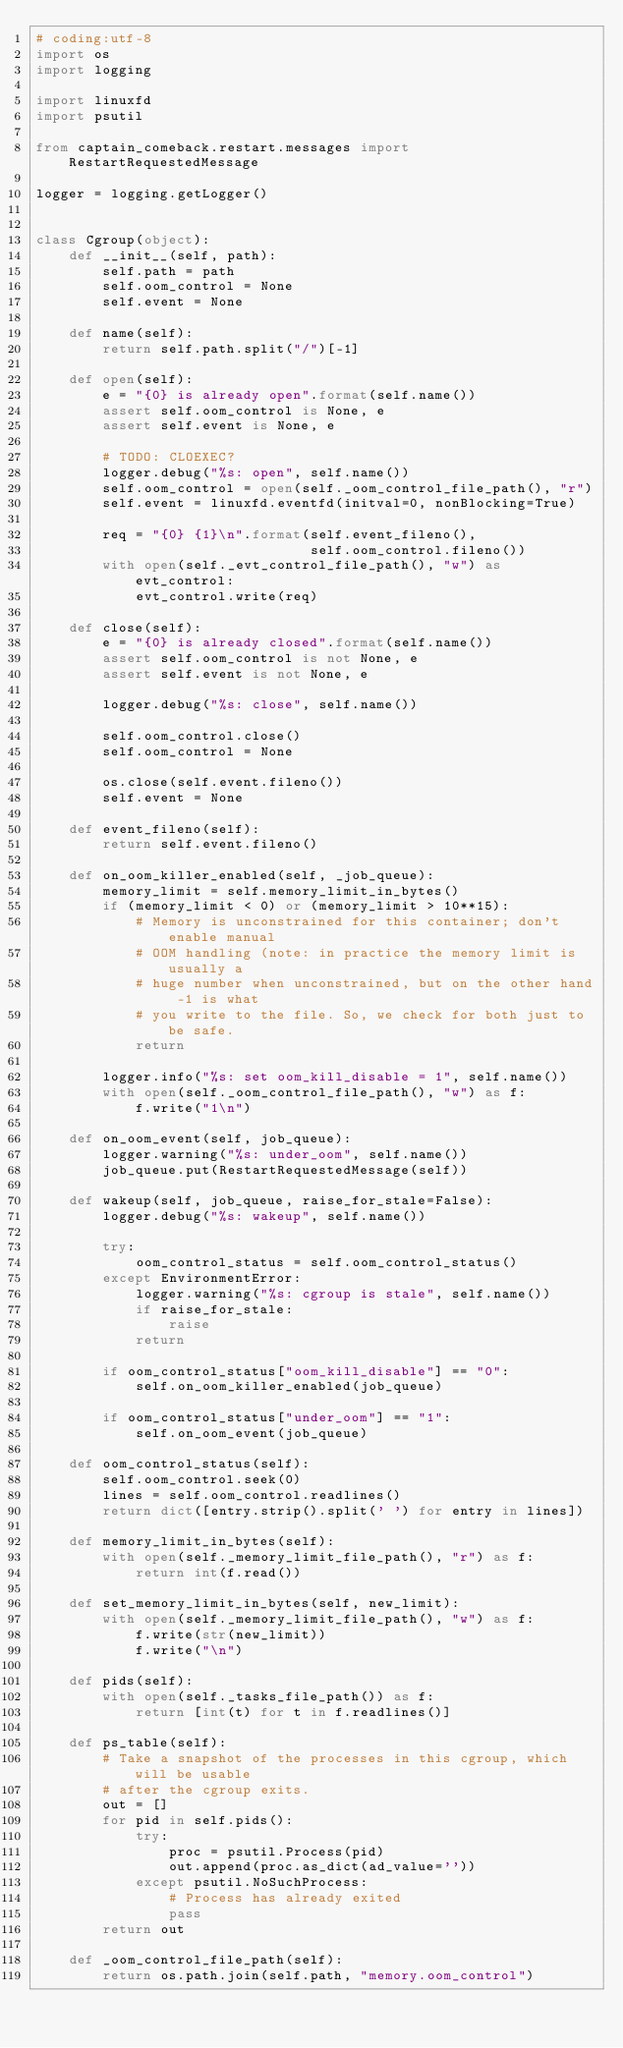<code> <loc_0><loc_0><loc_500><loc_500><_Python_># coding:utf-8
import os
import logging

import linuxfd
import psutil

from captain_comeback.restart.messages import RestartRequestedMessage

logger = logging.getLogger()


class Cgroup(object):
    def __init__(self, path):
        self.path = path
        self.oom_control = None
        self.event = None

    def name(self):
        return self.path.split("/")[-1]

    def open(self):
        e = "{0} is already open".format(self.name())
        assert self.oom_control is None, e
        assert self.event is None, e

        # TODO: CLOEXEC?
        logger.debug("%s: open", self.name())
        self.oom_control = open(self._oom_control_file_path(), "r")
        self.event = linuxfd.eventfd(initval=0, nonBlocking=True)

        req = "{0} {1}\n".format(self.event_fileno(),
                                 self.oom_control.fileno())
        with open(self._evt_control_file_path(), "w") as evt_control:
            evt_control.write(req)

    def close(self):
        e = "{0} is already closed".format(self.name())
        assert self.oom_control is not None, e
        assert self.event is not None, e

        logger.debug("%s: close", self.name())

        self.oom_control.close()
        self.oom_control = None

        os.close(self.event.fileno())
        self.event = None

    def event_fileno(self):
        return self.event.fileno()

    def on_oom_killer_enabled(self, _job_queue):
        memory_limit = self.memory_limit_in_bytes()
        if (memory_limit < 0) or (memory_limit > 10**15):
            # Memory is unconstrained for this container; don't enable manual
            # OOM handling (note: in practice the memory limit is usually a
            # huge number when unconstrained, but on the other hand -1 is what
            # you write to the file. So, we check for both just to be safe.
            return

        logger.info("%s: set oom_kill_disable = 1", self.name())
        with open(self._oom_control_file_path(), "w") as f:
            f.write("1\n")

    def on_oom_event(self, job_queue):
        logger.warning("%s: under_oom", self.name())
        job_queue.put(RestartRequestedMessage(self))

    def wakeup(self, job_queue, raise_for_stale=False):
        logger.debug("%s: wakeup", self.name())

        try:
            oom_control_status = self.oom_control_status()
        except EnvironmentError:
            logger.warning("%s: cgroup is stale", self.name())
            if raise_for_stale:
                raise
            return

        if oom_control_status["oom_kill_disable"] == "0":
            self.on_oom_killer_enabled(job_queue)

        if oom_control_status["under_oom"] == "1":
            self.on_oom_event(job_queue)

    def oom_control_status(self):
        self.oom_control.seek(0)
        lines = self.oom_control.readlines()
        return dict([entry.strip().split(' ') for entry in lines])

    def memory_limit_in_bytes(self):
        with open(self._memory_limit_file_path(), "r") as f:
            return int(f.read())

    def set_memory_limit_in_bytes(self, new_limit):
        with open(self._memory_limit_file_path(), "w") as f:
            f.write(str(new_limit))
            f.write("\n")

    def pids(self):
        with open(self._tasks_file_path()) as f:
            return [int(t) for t in f.readlines()]

    def ps_table(self):
        # Take a snapshot of the processes in this cgroup, which will be usable
        # after the cgroup exits.
        out = []
        for pid in self.pids():
            try:
                proc = psutil.Process(pid)
                out.append(proc.as_dict(ad_value=''))
            except psutil.NoSuchProcess:
                # Process has already exited
                pass
        return out

    def _oom_control_file_path(self):
        return os.path.join(self.path, "memory.oom_control")
</code> 